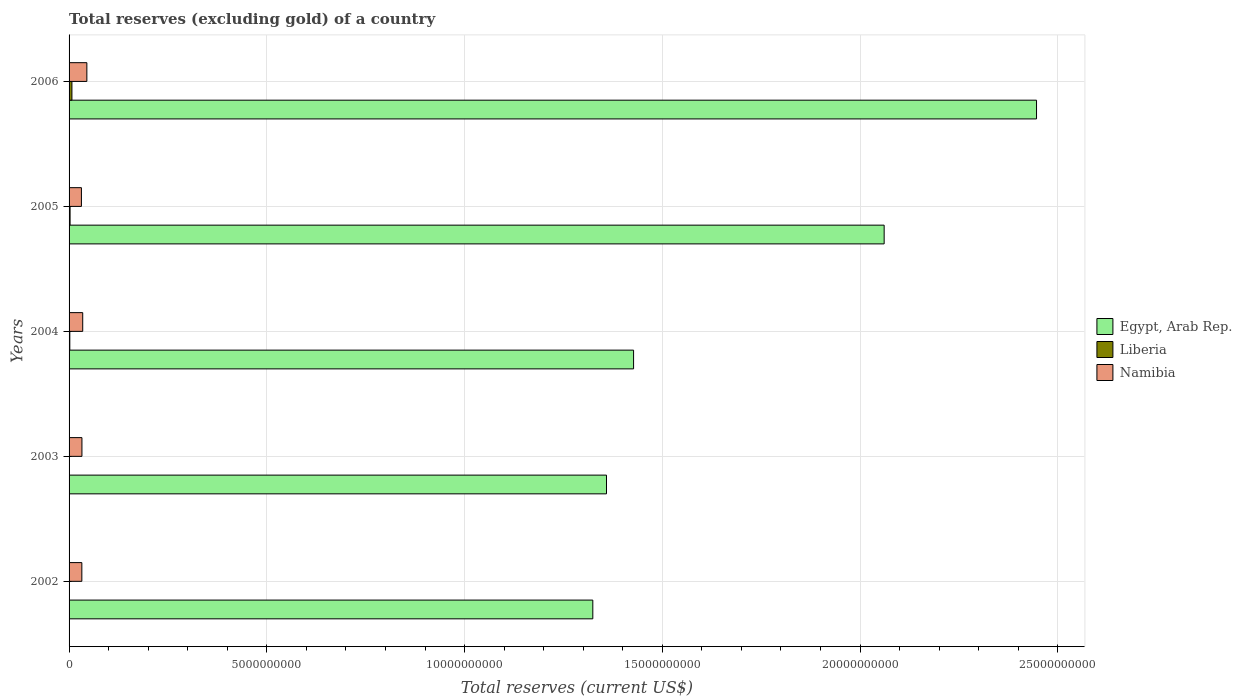How many groups of bars are there?
Your answer should be compact. 5. Are the number of bars per tick equal to the number of legend labels?
Provide a succinct answer. Yes. How many bars are there on the 1st tick from the bottom?
Provide a succinct answer. 3. In how many cases, is the number of bars for a given year not equal to the number of legend labels?
Offer a terse response. 0. What is the total reserves (excluding gold) in Namibia in 2002?
Your answer should be compact. 3.23e+08. Across all years, what is the maximum total reserves (excluding gold) in Liberia?
Offer a very short reply. 7.20e+07. Across all years, what is the minimum total reserves (excluding gold) in Liberia?
Keep it short and to the point. 3.30e+06. In which year was the total reserves (excluding gold) in Liberia maximum?
Provide a succinct answer. 2006. In which year was the total reserves (excluding gold) in Namibia minimum?
Provide a succinct answer. 2005. What is the total total reserves (excluding gold) in Namibia in the graph?
Your answer should be compact. 1.76e+09. What is the difference between the total reserves (excluding gold) in Liberia in 2002 and that in 2005?
Offer a terse response. -2.21e+07. What is the difference between the total reserves (excluding gold) in Liberia in 2006 and the total reserves (excluding gold) in Egypt, Arab Rep. in 2003?
Offer a very short reply. -1.35e+1. What is the average total reserves (excluding gold) in Liberia per year?
Offer a very short reply. 2.54e+07. In the year 2006, what is the difference between the total reserves (excluding gold) in Egypt, Arab Rep. and total reserves (excluding gold) in Namibia?
Your response must be concise. 2.40e+1. What is the ratio of the total reserves (excluding gold) in Egypt, Arab Rep. in 2002 to that in 2003?
Offer a terse response. 0.97. Is the difference between the total reserves (excluding gold) in Egypt, Arab Rep. in 2002 and 2005 greater than the difference between the total reserves (excluding gold) in Namibia in 2002 and 2005?
Ensure brevity in your answer.  No. What is the difference between the highest and the second highest total reserves (excluding gold) in Liberia?
Your answer should be very brief. 4.66e+07. What is the difference between the highest and the lowest total reserves (excluding gold) in Egypt, Arab Rep.?
Offer a very short reply. 1.12e+1. What does the 2nd bar from the top in 2005 represents?
Keep it short and to the point. Liberia. What does the 3rd bar from the bottom in 2004 represents?
Provide a succinct answer. Namibia. Are all the bars in the graph horizontal?
Your answer should be very brief. Yes. What is the difference between two consecutive major ticks on the X-axis?
Provide a short and direct response. 5.00e+09. Does the graph contain any zero values?
Keep it short and to the point. No. How many legend labels are there?
Provide a short and direct response. 3. How are the legend labels stacked?
Give a very brief answer. Vertical. What is the title of the graph?
Provide a short and direct response. Total reserves (excluding gold) of a country. Does "Somalia" appear as one of the legend labels in the graph?
Provide a short and direct response. No. What is the label or title of the X-axis?
Provide a short and direct response. Total reserves (current US$). What is the Total reserves (current US$) in Egypt, Arab Rep. in 2002?
Ensure brevity in your answer.  1.32e+1. What is the Total reserves (current US$) in Liberia in 2002?
Make the answer very short. 3.30e+06. What is the Total reserves (current US$) in Namibia in 2002?
Your response must be concise. 3.23e+08. What is the Total reserves (current US$) of Egypt, Arab Rep. in 2003?
Make the answer very short. 1.36e+1. What is the Total reserves (current US$) of Liberia in 2003?
Make the answer very short. 7.38e+06. What is the Total reserves (current US$) in Namibia in 2003?
Give a very brief answer. 3.25e+08. What is the Total reserves (current US$) in Egypt, Arab Rep. in 2004?
Provide a succinct answer. 1.43e+1. What is the Total reserves (current US$) of Liberia in 2004?
Your answer should be very brief. 1.87e+07. What is the Total reserves (current US$) of Namibia in 2004?
Your answer should be very brief. 3.45e+08. What is the Total reserves (current US$) in Egypt, Arab Rep. in 2005?
Give a very brief answer. 2.06e+1. What is the Total reserves (current US$) of Liberia in 2005?
Keep it short and to the point. 2.54e+07. What is the Total reserves (current US$) in Namibia in 2005?
Your response must be concise. 3.12e+08. What is the Total reserves (current US$) in Egypt, Arab Rep. in 2006?
Your answer should be compact. 2.45e+1. What is the Total reserves (current US$) of Liberia in 2006?
Provide a short and direct response. 7.20e+07. What is the Total reserves (current US$) of Namibia in 2006?
Keep it short and to the point. 4.50e+08. Across all years, what is the maximum Total reserves (current US$) of Egypt, Arab Rep.?
Your response must be concise. 2.45e+1. Across all years, what is the maximum Total reserves (current US$) in Liberia?
Your answer should be very brief. 7.20e+07. Across all years, what is the maximum Total reserves (current US$) of Namibia?
Give a very brief answer. 4.50e+08. Across all years, what is the minimum Total reserves (current US$) in Egypt, Arab Rep.?
Offer a very short reply. 1.32e+1. Across all years, what is the minimum Total reserves (current US$) in Liberia?
Offer a terse response. 3.30e+06. Across all years, what is the minimum Total reserves (current US$) of Namibia?
Your response must be concise. 3.12e+08. What is the total Total reserves (current US$) in Egypt, Arab Rep. in the graph?
Your answer should be very brief. 8.62e+1. What is the total Total reserves (current US$) of Liberia in the graph?
Give a very brief answer. 1.27e+08. What is the total Total reserves (current US$) of Namibia in the graph?
Ensure brevity in your answer.  1.76e+09. What is the difference between the Total reserves (current US$) in Egypt, Arab Rep. in 2002 and that in 2003?
Provide a succinct answer. -3.46e+08. What is the difference between the Total reserves (current US$) in Liberia in 2002 and that in 2003?
Ensure brevity in your answer.  -4.08e+06. What is the difference between the Total reserves (current US$) of Namibia in 2002 and that in 2003?
Offer a very short reply. -2.08e+06. What is the difference between the Total reserves (current US$) of Egypt, Arab Rep. in 2002 and that in 2004?
Provide a succinct answer. -1.03e+09. What is the difference between the Total reserves (current US$) of Liberia in 2002 and that in 2004?
Keep it short and to the point. -1.54e+07. What is the difference between the Total reserves (current US$) of Namibia in 2002 and that in 2004?
Make the answer very short. -2.19e+07. What is the difference between the Total reserves (current US$) in Egypt, Arab Rep. in 2002 and that in 2005?
Make the answer very short. -7.37e+09. What is the difference between the Total reserves (current US$) in Liberia in 2002 and that in 2005?
Provide a short and direct response. -2.21e+07. What is the difference between the Total reserves (current US$) of Namibia in 2002 and that in 2005?
Provide a succinct answer. 1.10e+07. What is the difference between the Total reserves (current US$) of Egypt, Arab Rep. in 2002 and that in 2006?
Your answer should be very brief. -1.12e+1. What is the difference between the Total reserves (current US$) in Liberia in 2002 and that in 2006?
Give a very brief answer. -6.87e+07. What is the difference between the Total reserves (current US$) of Namibia in 2002 and that in 2006?
Offer a terse response. -1.26e+08. What is the difference between the Total reserves (current US$) of Egypt, Arab Rep. in 2003 and that in 2004?
Provide a short and direct response. -6.84e+08. What is the difference between the Total reserves (current US$) of Liberia in 2003 and that in 2004?
Your response must be concise. -1.14e+07. What is the difference between the Total reserves (current US$) of Namibia in 2003 and that in 2004?
Provide a short and direct response. -1.98e+07. What is the difference between the Total reserves (current US$) of Egypt, Arab Rep. in 2003 and that in 2005?
Offer a terse response. -7.02e+09. What is the difference between the Total reserves (current US$) in Liberia in 2003 and that in 2005?
Give a very brief answer. -1.80e+07. What is the difference between the Total reserves (current US$) in Namibia in 2003 and that in 2005?
Provide a succinct answer. 1.31e+07. What is the difference between the Total reserves (current US$) of Egypt, Arab Rep. in 2003 and that in 2006?
Provide a succinct answer. -1.09e+1. What is the difference between the Total reserves (current US$) of Liberia in 2003 and that in 2006?
Your answer should be compact. -6.46e+07. What is the difference between the Total reserves (current US$) in Namibia in 2003 and that in 2006?
Keep it short and to the point. -1.24e+08. What is the difference between the Total reserves (current US$) in Egypt, Arab Rep. in 2004 and that in 2005?
Offer a terse response. -6.34e+09. What is the difference between the Total reserves (current US$) of Liberia in 2004 and that in 2005?
Your answer should be very brief. -6.65e+06. What is the difference between the Total reserves (current US$) of Namibia in 2004 and that in 2005?
Your response must be concise. 3.30e+07. What is the difference between the Total reserves (current US$) in Egypt, Arab Rep. in 2004 and that in 2006?
Make the answer very short. -1.02e+1. What is the difference between the Total reserves (current US$) in Liberia in 2004 and that in 2006?
Ensure brevity in your answer.  -5.32e+07. What is the difference between the Total reserves (current US$) of Namibia in 2004 and that in 2006?
Your answer should be compact. -1.05e+08. What is the difference between the Total reserves (current US$) of Egypt, Arab Rep. in 2005 and that in 2006?
Keep it short and to the point. -3.85e+09. What is the difference between the Total reserves (current US$) of Liberia in 2005 and that in 2006?
Offer a very short reply. -4.66e+07. What is the difference between the Total reserves (current US$) in Namibia in 2005 and that in 2006?
Make the answer very short. -1.37e+08. What is the difference between the Total reserves (current US$) in Egypt, Arab Rep. in 2002 and the Total reserves (current US$) in Liberia in 2003?
Offer a terse response. 1.32e+1. What is the difference between the Total reserves (current US$) of Egypt, Arab Rep. in 2002 and the Total reserves (current US$) of Namibia in 2003?
Your response must be concise. 1.29e+1. What is the difference between the Total reserves (current US$) in Liberia in 2002 and the Total reserves (current US$) in Namibia in 2003?
Your response must be concise. -3.22e+08. What is the difference between the Total reserves (current US$) of Egypt, Arab Rep. in 2002 and the Total reserves (current US$) of Liberia in 2004?
Provide a short and direct response. 1.32e+1. What is the difference between the Total reserves (current US$) of Egypt, Arab Rep. in 2002 and the Total reserves (current US$) of Namibia in 2004?
Keep it short and to the point. 1.29e+1. What is the difference between the Total reserves (current US$) in Liberia in 2002 and the Total reserves (current US$) in Namibia in 2004?
Your answer should be very brief. -3.42e+08. What is the difference between the Total reserves (current US$) in Egypt, Arab Rep. in 2002 and the Total reserves (current US$) in Liberia in 2005?
Your response must be concise. 1.32e+1. What is the difference between the Total reserves (current US$) of Egypt, Arab Rep. in 2002 and the Total reserves (current US$) of Namibia in 2005?
Provide a succinct answer. 1.29e+1. What is the difference between the Total reserves (current US$) of Liberia in 2002 and the Total reserves (current US$) of Namibia in 2005?
Your answer should be compact. -3.09e+08. What is the difference between the Total reserves (current US$) in Egypt, Arab Rep. in 2002 and the Total reserves (current US$) in Liberia in 2006?
Give a very brief answer. 1.32e+1. What is the difference between the Total reserves (current US$) in Egypt, Arab Rep. in 2002 and the Total reserves (current US$) in Namibia in 2006?
Keep it short and to the point. 1.28e+1. What is the difference between the Total reserves (current US$) in Liberia in 2002 and the Total reserves (current US$) in Namibia in 2006?
Offer a very short reply. -4.46e+08. What is the difference between the Total reserves (current US$) in Egypt, Arab Rep. in 2003 and the Total reserves (current US$) in Liberia in 2004?
Ensure brevity in your answer.  1.36e+1. What is the difference between the Total reserves (current US$) of Egypt, Arab Rep. in 2003 and the Total reserves (current US$) of Namibia in 2004?
Provide a short and direct response. 1.32e+1. What is the difference between the Total reserves (current US$) of Liberia in 2003 and the Total reserves (current US$) of Namibia in 2004?
Your response must be concise. -3.38e+08. What is the difference between the Total reserves (current US$) in Egypt, Arab Rep. in 2003 and the Total reserves (current US$) in Liberia in 2005?
Make the answer very short. 1.36e+1. What is the difference between the Total reserves (current US$) of Egypt, Arab Rep. in 2003 and the Total reserves (current US$) of Namibia in 2005?
Offer a terse response. 1.33e+1. What is the difference between the Total reserves (current US$) of Liberia in 2003 and the Total reserves (current US$) of Namibia in 2005?
Your answer should be very brief. -3.05e+08. What is the difference between the Total reserves (current US$) in Egypt, Arab Rep. in 2003 and the Total reserves (current US$) in Liberia in 2006?
Your answer should be compact. 1.35e+1. What is the difference between the Total reserves (current US$) of Egypt, Arab Rep. in 2003 and the Total reserves (current US$) of Namibia in 2006?
Offer a very short reply. 1.31e+1. What is the difference between the Total reserves (current US$) of Liberia in 2003 and the Total reserves (current US$) of Namibia in 2006?
Ensure brevity in your answer.  -4.42e+08. What is the difference between the Total reserves (current US$) of Egypt, Arab Rep. in 2004 and the Total reserves (current US$) of Liberia in 2005?
Your answer should be very brief. 1.42e+1. What is the difference between the Total reserves (current US$) of Egypt, Arab Rep. in 2004 and the Total reserves (current US$) of Namibia in 2005?
Your response must be concise. 1.40e+1. What is the difference between the Total reserves (current US$) in Liberia in 2004 and the Total reserves (current US$) in Namibia in 2005?
Make the answer very short. -2.93e+08. What is the difference between the Total reserves (current US$) of Egypt, Arab Rep. in 2004 and the Total reserves (current US$) of Liberia in 2006?
Keep it short and to the point. 1.42e+1. What is the difference between the Total reserves (current US$) of Egypt, Arab Rep. in 2004 and the Total reserves (current US$) of Namibia in 2006?
Keep it short and to the point. 1.38e+1. What is the difference between the Total reserves (current US$) in Liberia in 2004 and the Total reserves (current US$) in Namibia in 2006?
Your response must be concise. -4.31e+08. What is the difference between the Total reserves (current US$) of Egypt, Arab Rep. in 2005 and the Total reserves (current US$) of Liberia in 2006?
Give a very brief answer. 2.05e+1. What is the difference between the Total reserves (current US$) of Egypt, Arab Rep. in 2005 and the Total reserves (current US$) of Namibia in 2006?
Provide a short and direct response. 2.02e+1. What is the difference between the Total reserves (current US$) in Liberia in 2005 and the Total reserves (current US$) in Namibia in 2006?
Give a very brief answer. -4.24e+08. What is the average Total reserves (current US$) of Egypt, Arab Rep. per year?
Keep it short and to the point. 1.72e+1. What is the average Total reserves (current US$) of Liberia per year?
Give a very brief answer. 2.54e+07. What is the average Total reserves (current US$) of Namibia per year?
Give a very brief answer. 3.51e+08. In the year 2002, what is the difference between the Total reserves (current US$) of Egypt, Arab Rep. and Total reserves (current US$) of Liberia?
Ensure brevity in your answer.  1.32e+1. In the year 2002, what is the difference between the Total reserves (current US$) of Egypt, Arab Rep. and Total reserves (current US$) of Namibia?
Provide a succinct answer. 1.29e+1. In the year 2002, what is the difference between the Total reserves (current US$) of Liberia and Total reserves (current US$) of Namibia?
Make the answer very short. -3.20e+08. In the year 2003, what is the difference between the Total reserves (current US$) in Egypt, Arab Rep. and Total reserves (current US$) in Liberia?
Your answer should be compact. 1.36e+1. In the year 2003, what is the difference between the Total reserves (current US$) in Egypt, Arab Rep. and Total reserves (current US$) in Namibia?
Keep it short and to the point. 1.33e+1. In the year 2003, what is the difference between the Total reserves (current US$) of Liberia and Total reserves (current US$) of Namibia?
Your answer should be very brief. -3.18e+08. In the year 2004, what is the difference between the Total reserves (current US$) in Egypt, Arab Rep. and Total reserves (current US$) in Liberia?
Make the answer very short. 1.43e+1. In the year 2004, what is the difference between the Total reserves (current US$) in Egypt, Arab Rep. and Total reserves (current US$) in Namibia?
Make the answer very short. 1.39e+1. In the year 2004, what is the difference between the Total reserves (current US$) of Liberia and Total reserves (current US$) of Namibia?
Provide a succinct answer. -3.26e+08. In the year 2005, what is the difference between the Total reserves (current US$) of Egypt, Arab Rep. and Total reserves (current US$) of Liberia?
Provide a short and direct response. 2.06e+1. In the year 2005, what is the difference between the Total reserves (current US$) of Egypt, Arab Rep. and Total reserves (current US$) of Namibia?
Keep it short and to the point. 2.03e+1. In the year 2005, what is the difference between the Total reserves (current US$) in Liberia and Total reserves (current US$) in Namibia?
Ensure brevity in your answer.  -2.87e+08. In the year 2006, what is the difference between the Total reserves (current US$) of Egypt, Arab Rep. and Total reserves (current US$) of Liberia?
Provide a short and direct response. 2.44e+1. In the year 2006, what is the difference between the Total reserves (current US$) of Egypt, Arab Rep. and Total reserves (current US$) of Namibia?
Make the answer very short. 2.40e+1. In the year 2006, what is the difference between the Total reserves (current US$) in Liberia and Total reserves (current US$) in Namibia?
Keep it short and to the point. -3.78e+08. What is the ratio of the Total reserves (current US$) of Egypt, Arab Rep. in 2002 to that in 2003?
Give a very brief answer. 0.97. What is the ratio of the Total reserves (current US$) in Liberia in 2002 to that in 2003?
Give a very brief answer. 0.45. What is the ratio of the Total reserves (current US$) in Egypt, Arab Rep. in 2002 to that in 2004?
Your response must be concise. 0.93. What is the ratio of the Total reserves (current US$) in Liberia in 2002 to that in 2004?
Your response must be concise. 0.18. What is the ratio of the Total reserves (current US$) in Namibia in 2002 to that in 2004?
Provide a short and direct response. 0.94. What is the ratio of the Total reserves (current US$) in Egypt, Arab Rep. in 2002 to that in 2005?
Keep it short and to the point. 0.64. What is the ratio of the Total reserves (current US$) in Liberia in 2002 to that in 2005?
Ensure brevity in your answer.  0.13. What is the ratio of the Total reserves (current US$) in Namibia in 2002 to that in 2005?
Offer a very short reply. 1.04. What is the ratio of the Total reserves (current US$) of Egypt, Arab Rep. in 2002 to that in 2006?
Your response must be concise. 0.54. What is the ratio of the Total reserves (current US$) in Liberia in 2002 to that in 2006?
Provide a short and direct response. 0.05. What is the ratio of the Total reserves (current US$) in Namibia in 2002 to that in 2006?
Offer a very short reply. 0.72. What is the ratio of the Total reserves (current US$) of Egypt, Arab Rep. in 2003 to that in 2004?
Make the answer very short. 0.95. What is the ratio of the Total reserves (current US$) of Liberia in 2003 to that in 2004?
Your answer should be compact. 0.39. What is the ratio of the Total reserves (current US$) of Namibia in 2003 to that in 2004?
Provide a short and direct response. 0.94. What is the ratio of the Total reserves (current US$) in Egypt, Arab Rep. in 2003 to that in 2005?
Provide a succinct answer. 0.66. What is the ratio of the Total reserves (current US$) in Liberia in 2003 to that in 2005?
Your response must be concise. 0.29. What is the ratio of the Total reserves (current US$) in Namibia in 2003 to that in 2005?
Keep it short and to the point. 1.04. What is the ratio of the Total reserves (current US$) of Egypt, Arab Rep. in 2003 to that in 2006?
Offer a very short reply. 0.56. What is the ratio of the Total reserves (current US$) in Liberia in 2003 to that in 2006?
Your response must be concise. 0.1. What is the ratio of the Total reserves (current US$) in Namibia in 2003 to that in 2006?
Keep it short and to the point. 0.72. What is the ratio of the Total reserves (current US$) of Egypt, Arab Rep. in 2004 to that in 2005?
Make the answer very short. 0.69. What is the ratio of the Total reserves (current US$) in Liberia in 2004 to that in 2005?
Make the answer very short. 0.74. What is the ratio of the Total reserves (current US$) of Namibia in 2004 to that in 2005?
Your answer should be very brief. 1.11. What is the ratio of the Total reserves (current US$) of Egypt, Arab Rep. in 2004 to that in 2006?
Your response must be concise. 0.58. What is the ratio of the Total reserves (current US$) of Liberia in 2004 to that in 2006?
Offer a very short reply. 0.26. What is the ratio of the Total reserves (current US$) of Namibia in 2004 to that in 2006?
Offer a terse response. 0.77. What is the ratio of the Total reserves (current US$) of Egypt, Arab Rep. in 2005 to that in 2006?
Give a very brief answer. 0.84. What is the ratio of the Total reserves (current US$) of Liberia in 2005 to that in 2006?
Your answer should be very brief. 0.35. What is the ratio of the Total reserves (current US$) in Namibia in 2005 to that in 2006?
Give a very brief answer. 0.69. What is the difference between the highest and the second highest Total reserves (current US$) of Egypt, Arab Rep.?
Keep it short and to the point. 3.85e+09. What is the difference between the highest and the second highest Total reserves (current US$) of Liberia?
Your answer should be compact. 4.66e+07. What is the difference between the highest and the second highest Total reserves (current US$) in Namibia?
Your response must be concise. 1.05e+08. What is the difference between the highest and the lowest Total reserves (current US$) of Egypt, Arab Rep.?
Offer a very short reply. 1.12e+1. What is the difference between the highest and the lowest Total reserves (current US$) of Liberia?
Give a very brief answer. 6.87e+07. What is the difference between the highest and the lowest Total reserves (current US$) of Namibia?
Give a very brief answer. 1.37e+08. 